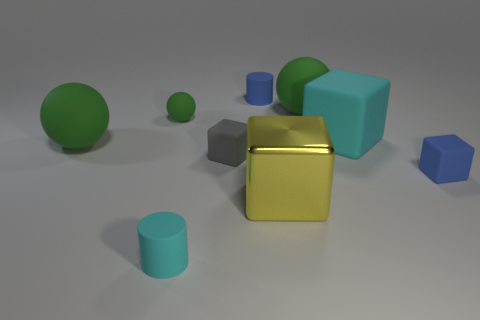Is there a source of light in the scene, and how does it affect the appearance of the objects? While there's no visible source of light in the image, illumination seems to come from the upper right, casting soft shadows on the left side of the objects. This lighting creates highlights and shadows that enhance the three-dimensional form of the objects and indicates the direction of the light source. 